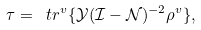<formula> <loc_0><loc_0><loc_500><loc_500>\tau = \ t r ^ { v } \{ \mathcal { Y } ( \mathcal { I } - \mathcal { N } ) ^ { - 2 } \rho ^ { v } \} ,</formula> 